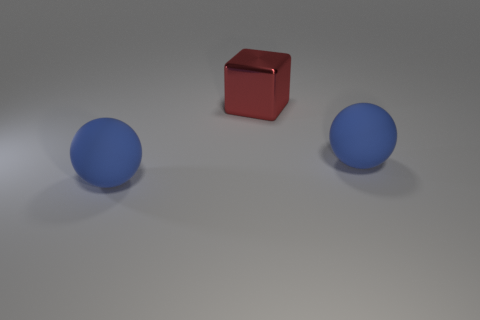Are there any other things that are the same material as the red object?
Offer a terse response. No. What number of big red cubes have the same material as the red thing?
Offer a terse response. 0. There is a big rubber ball in front of the large thing right of the big cube; is there a big metal cube that is in front of it?
Provide a succinct answer. No. How many spheres are big metal objects or blue rubber objects?
Ensure brevity in your answer.  2. Is the number of large blue balls that are to the left of the large red block less than the number of large red things?
Give a very brief answer. No. There is a big metallic cube; are there any big rubber objects on the right side of it?
Make the answer very short. Yes. How many things are big objects that are in front of the large red shiny block or large red blocks?
Your answer should be compact. 3. Are there any blue matte balls of the same size as the block?
Provide a short and direct response. Yes. There is a sphere that is to the left of the metallic thing; is its size the same as the red metal object?
Offer a very short reply. Yes. The red shiny thing is what size?
Provide a short and direct response. Large. 